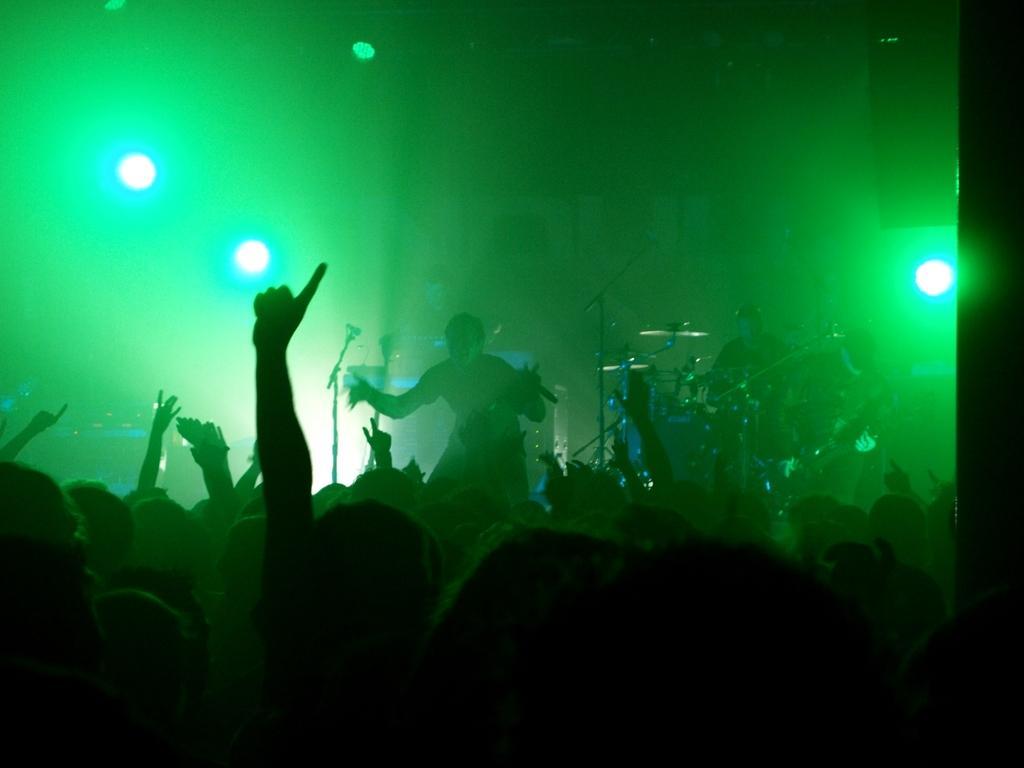Could you give a brief overview of what you see in this image? In this picture there is a man on the stage on the right side of the image and there is a drum set in front of him and there are other people those who are singing on the stage, in the center of the image, there are group of people as audience at bottom side of the image and there are spot lights on the right and left side of the image. 